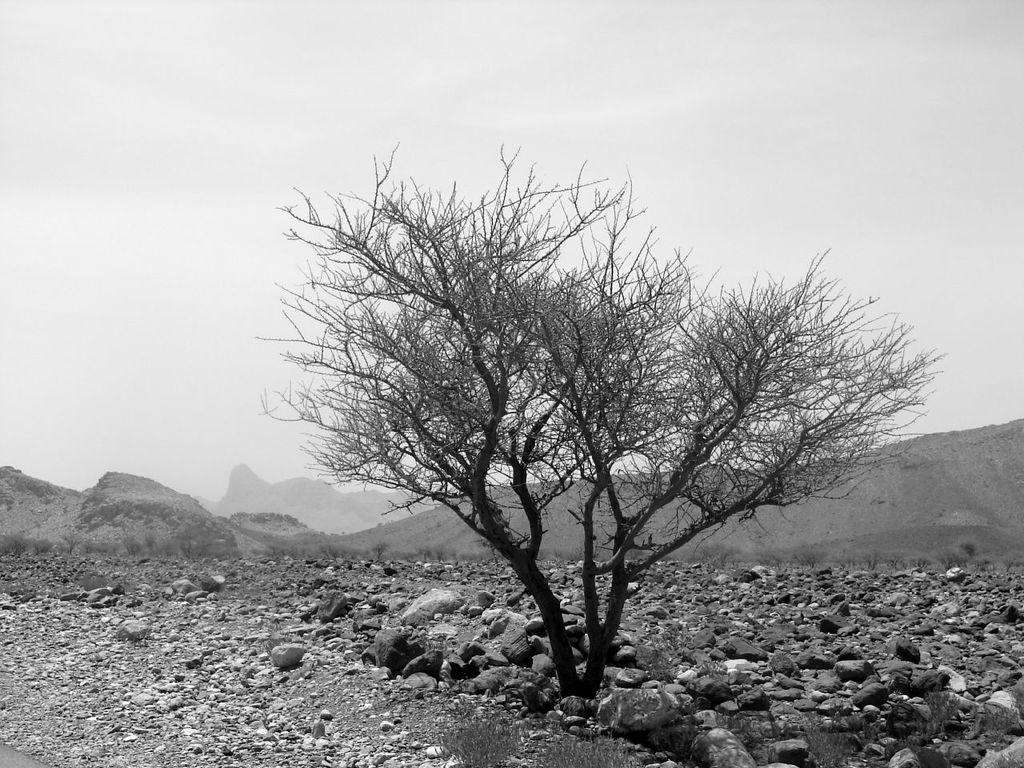What type of natural elements can be seen on the ground in the image? There are stones on the ground in the front of the image. What is located in the center of the image? There is a tree in the center of the image. What type of landscape feature is visible in the background of the image? There are mountains in the background of the image. How would you describe the sky in the image? The sky is cloudy in the image. How many sisters are sitting under the tree in the image? There are no sisters present in the image; it only features stones, a tree, mountains, and a cloudy sky. What type of leaf is falling from the tree in the image? There is no leaf falling from the tree in the image; it only features stones, a tree, mountains, and a cloudy sky. 